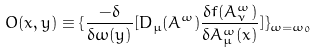Convert formula to latex. <formula><loc_0><loc_0><loc_500><loc_500>O ( x , y ) \equiv \{ \frac { - \delta } { \delta \omega ( y ) } [ D _ { \mu } ( A ^ { \omega } ) \frac { \delta f ( A ^ { \omega } _ { \nu } ) } { \delta A _ { \mu } ^ { \omega } ( x ) } ] \} _ { \omega = \omega _ { 0 } }</formula> 